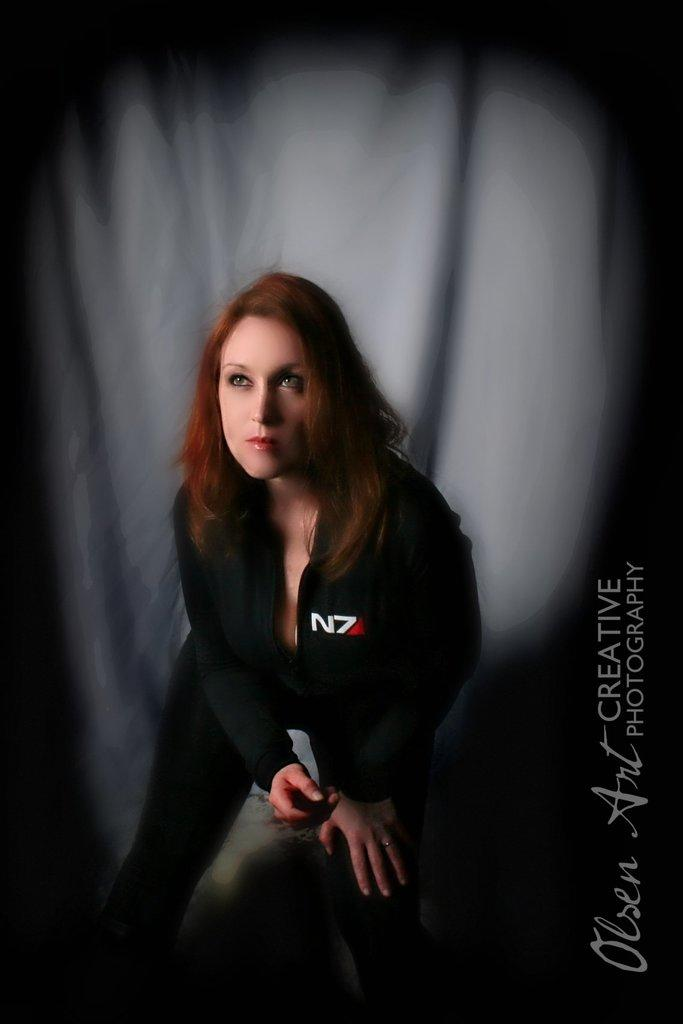Who is present in the image? There is a woman in the image. What is the woman wearing? The woman is wearing a jacket and trousers. What is the woman doing in the image? The woman is sitting. How would you describe the woman's hairstyle? The woman has short hair. What can be seen on the right side of the image? There is text on the right side of the image. What is visible in the background of the image? There is a cloth visible in the background of the image. What country is the woman flying over in the image? The image does not depict the woman flying over any country; she is sitting. What part of the woman's body is visible in the image? The image only shows the woman's upper body, so it is not possible to determine which specific body part is visible. 